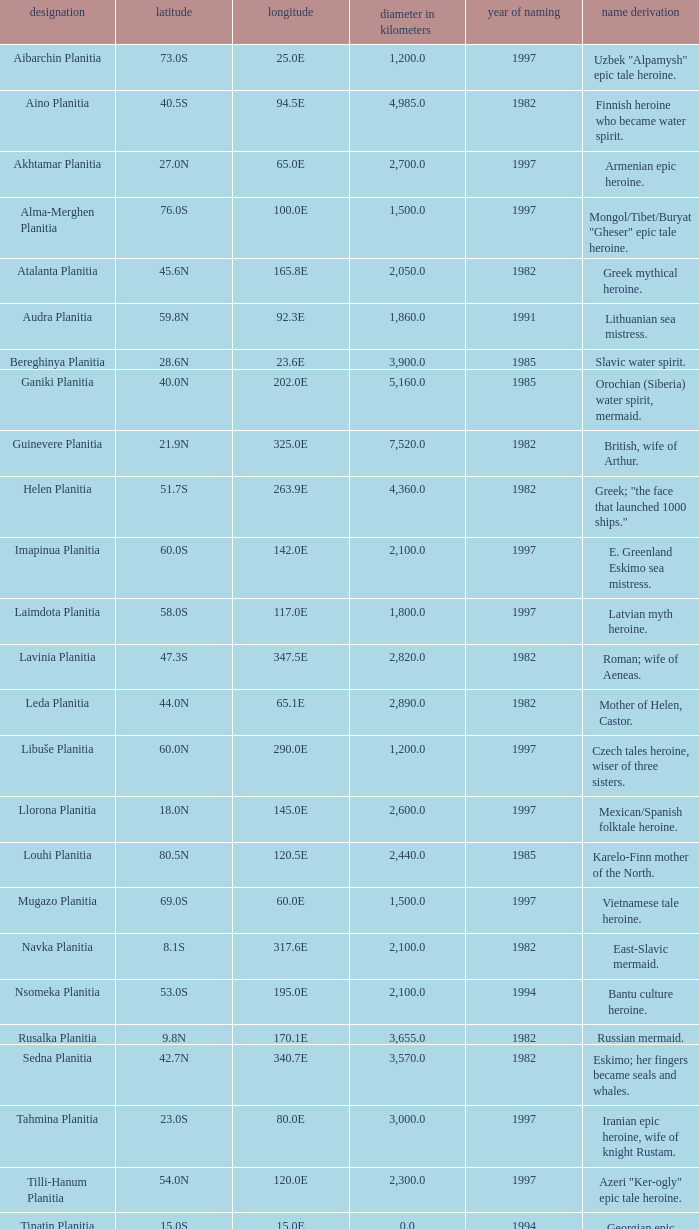What is the latitude of the feature of longitude 80.0e 23.0S. Can you give me this table as a dict? {'header': ['designation', 'latitude', 'longitude', 'diameter in kilometers', 'year of naming', 'name derivation'], 'rows': [['Aibarchin Planitia', '73.0S', '25.0E', '1,200.0', '1997', 'Uzbek "Alpamysh" epic tale heroine.'], ['Aino Planitia', '40.5S', '94.5E', '4,985.0', '1982', 'Finnish heroine who became water spirit.'], ['Akhtamar Planitia', '27.0N', '65.0E', '2,700.0', '1997', 'Armenian epic heroine.'], ['Alma-Merghen Planitia', '76.0S', '100.0E', '1,500.0', '1997', 'Mongol/Tibet/Buryat "Gheser" epic tale heroine.'], ['Atalanta Planitia', '45.6N', '165.8E', '2,050.0', '1982', 'Greek mythical heroine.'], ['Audra Planitia', '59.8N', '92.3E', '1,860.0', '1991', 'Lithuanian sea mistress.'], ['Bereghinya Planitia', '28.6N', '23.6E', '3,900.0', '1985', 'Slavic water spirit.'], ['Ganiki Planitia', '40.0N', '202.0E', '5,160.0', '1985', 'Orochian (Siberia) water spirit, mermaid.'], ['Guinevere Planitia', '21.9N', '325.0E', '7,520.0', '1982', 'British, wife of Arthur.'], ['Helen Planitia', '51.7S', '263.9E', '4,360.0', '1982', 'Greek; "the face that launched 1000 ships."'], ['Imapinua Planitia', '60.0S', '142.0E', '2,100.0', '1997', 'E. Greenland Eskimo sea mistress.'], ['Laimdota Planitia', '58.0S', '117.0E', '1,800.0', '1997', 'Latvian myth heroine.'], ['Lavinia Planitia', '47.3S', '347.5E', '2,820.0', '1982', 'Roman; wife of Aeneas.'], ['Leda Planitia', '44.0N', '65.1E', '2,890.0', '1982', 'Mother of Helen, Castor.'], ['Libuše Planitia', '60.0N', '290.0E', '1,200.0', '1997', 'Czech tales heroine, wiser of three sisters.'], ['Llorona Planitia', '18.0N', '145.0E', '2,600.0', '1997', 'Mexican/Spanish folktale heroine.'], ['Louhi Planitia', '80.5N', '120.5E', '2,440.0', '1985', 'Karelo-Finn mother of the North.'], ['Mugazo Planitia', '69.0S', '60.0E', '1,500.0', '1997', 'Vietnamese tale heroine.'], ['Navka Planitia', '8.1S', '317.6E', '2,100.0', '1982', 'East-Slavic mermaid.'], ['Nsomeka Planitia', '53.0S', '195.0E', '2,100.0', '1994', 'Bantu culture heroine.'], ['Rusalka Planitia', '9.8N', '170.1E', '3,655.0', '1982', 'Russian mermaid.'], ['Sedna Planitia', '42.7N', '340.7E', '3,570.0', '1982', 'Eskimo; her fingers became seals and whales.'], ['Tahmina Planitia', '23.0S', '80.0E', '3,000.0', '1997', 'Iranian epic heroine, wife of knight Rustam.'], ['Tilli-Hanum Planitia', '54.0N', '120.0E', '2,300.0', '1997', 'Azeri "Ker-ogly" epic tale heroine.'], ['Tinatin Planitia', '15.0S', '15.0E', '0.0', '1994', 'Georgian epic heroine.'], ['Undine Planitia', '13.0N', '303.0E', '2,800.0', '1997', 'Lithuanian water nymph, mermaid.'], ['Vellamo Planitia', '45.4N', '149.1E', '2,155.0', '1985', 'Karelo-Finn mermaid.']]} 